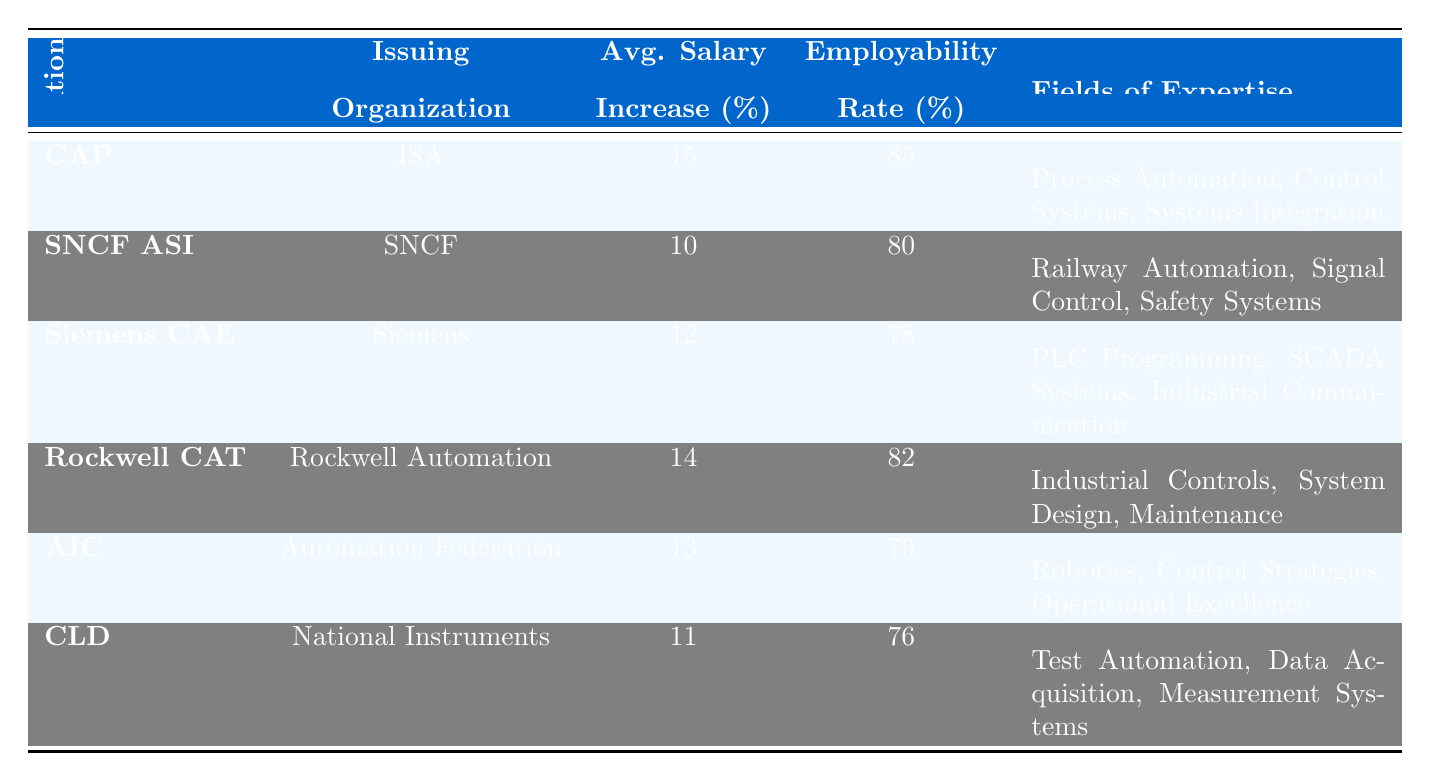What is the average salary increase percentage for the Certified Automation Professional (CAP)? According to the table, the average salary increase percentage for CAP is directly stated in the column under "Avg. Salary Increase (%)". It shows a percentage of 15.
Answer: 15 Which certification has the highest employability rate? The employability rates for the certifications can be found in the "Employability Rate (%)" column. By comparing the values, the highest employability rate is 85%, which belongs to the Certified Automation Professional (CAP).
Answer: CAP What is the average employability rate for all listed certifications? To find this, we add up the employability rates: 85 + 80 + 78 + 82 + 79 + 76 = 480. Then we divide by the total number of certifications, which is 6. Thus, the average is 480/6 = 80.
Answer: 80 Is the average salary increase percentage for Rockwell Certified Automation Technician higher than that for Siemens Certified Automation Engineer? By checking the "Avg. Salary Increase (%)" values, Rockwell's is 14 while Siemens' is 12. Since 14 is greater than 12, the statement is true.
Answer: Yes What fields of expertise are covered by the Automation Industry Certification (AIC)? The fields of expertise for AIC are listed in the corresponding column under "Fields of Expertise". They include Robotics, Control Strategies, and Operational Excellence.
Answer: Robotics, Control Strategies, Operational Excellence What is the difference in employability rates between the Certified Automation Professional (CAP) and the Certified LabVIEW Developer (CLD)? The employability rate for CAP is 85% and for CLD it is 76%. The difference is calculated by subtracting CLD's rate from CAP's (85 - 76) = 9%.
Answer: 9% Do both the Siemens Certified Automation Engineer and Rockwell Certified Automation Technician have an average salary increase percentage above 11%? The average salary increase for Siemens is 12% and for Rockwell, it is 14%. Both values are above 11%, so the statement is true.
Answer: Yes Which certification has the lowest average salary increase percentage? By reviewing the "Avg. Salary Increase (%)" column, the lowest percentage is 10% which is associated with the SNCF Automated Systems Integration Certification.
Answer: SNCF Automated Systems Integration Certification What certification has an employability rate of 78%? The "Employability Rate (%)" column shows that the Siemens Certified Automation Engineer has an employability rate of 78%.
Answer: Siemens Certified Automation Engineer What is the combined average salary increase percentage of the certifications issued by Siemens and Rockwell Automation? The average salary increase for Siemens is 12% and for Rockwell is 14%. To find the combined average, add these and divide by 2: (12 + 14) / 2 = 13%.
Answer: 13% 